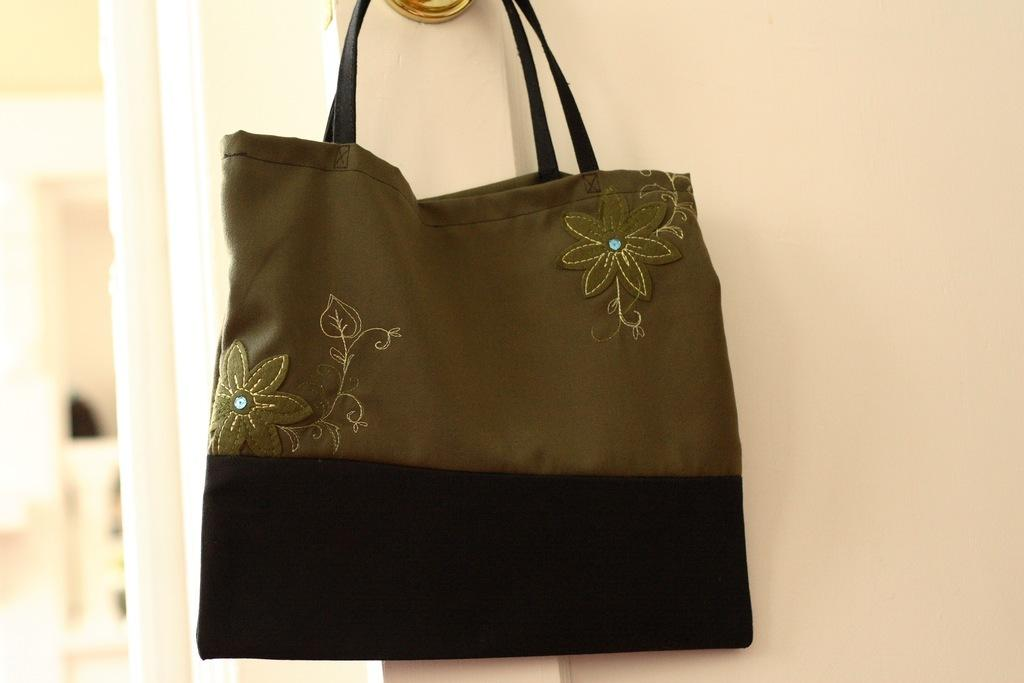What object can be seen hanging in the image? There is a handbag in the image, and it is in a hanging position. What design is featured on the handbag? The handbag has a flower design on it. Where is the structure of the sink located in the image? There is no sink present in the image; it only features a handbag with a flower design. What type of cabbage is growing in the image? There is no cabbage present in the image; it only features a handbag with a flower design. 